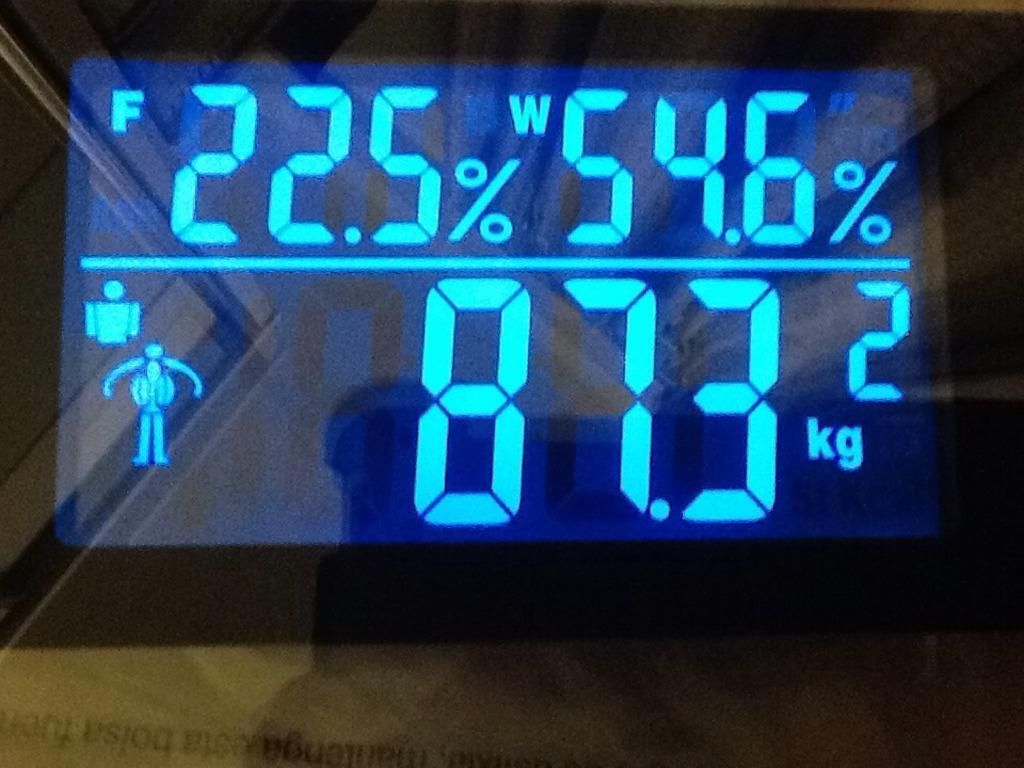Provide a one-sentence caption for the provided image. Digital screen or monitor showing the weight at 87.3 kg. 